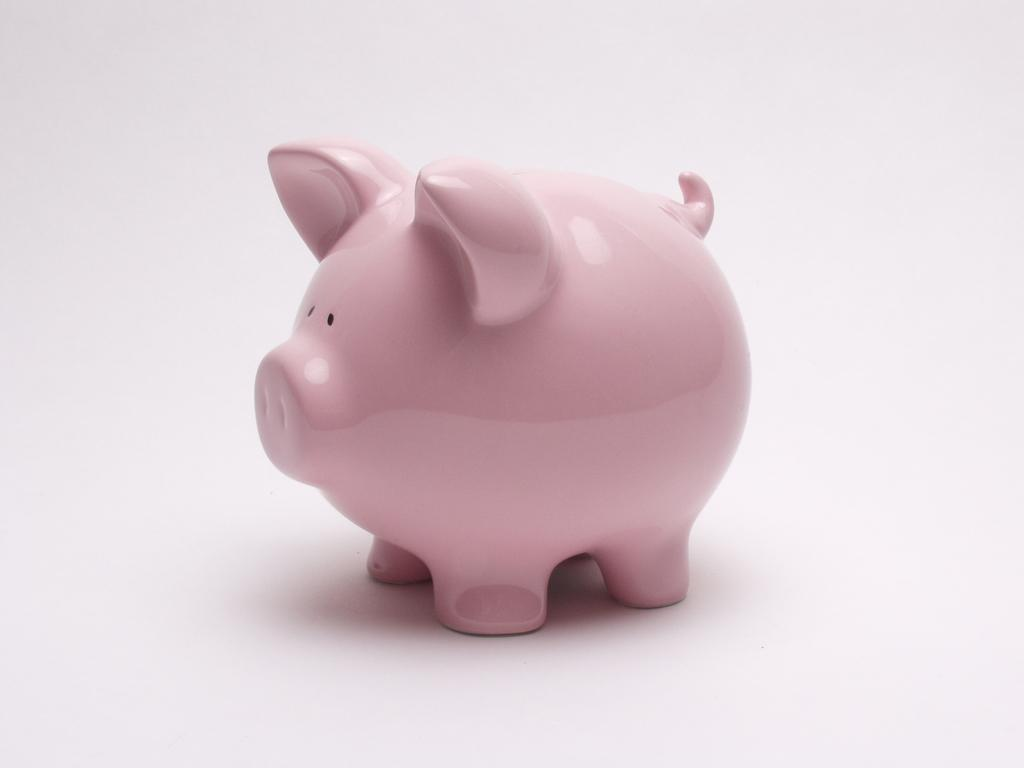What object is the main focus of the image? There is a piggy bank in the image. Can you describe the surface on which the piggy bank is placed? The piggy bank is on a plain surface. What type of bell can be heard ringing in the image? There is no bell present in the image, so it is not possible to hear it ringing. 